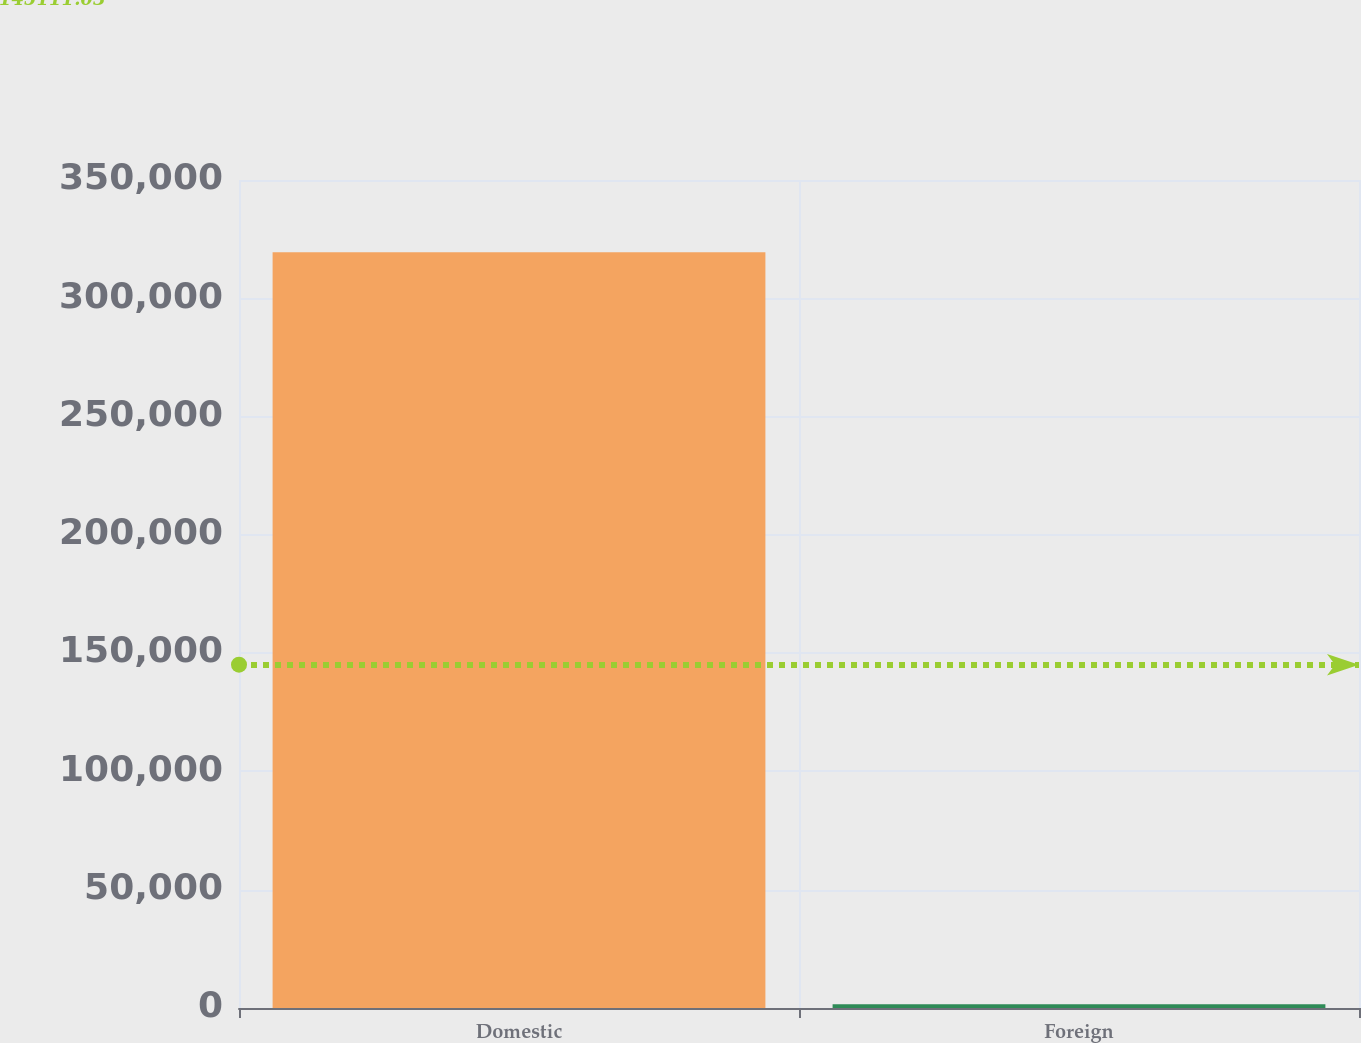Convert chart. <chart><loc_0><loc_0><loc_500><loc_500><bar_chart><fcel>Domestic<fcel>Foreign<nl><fcel>319494<fcel>1535<nl></chart> 